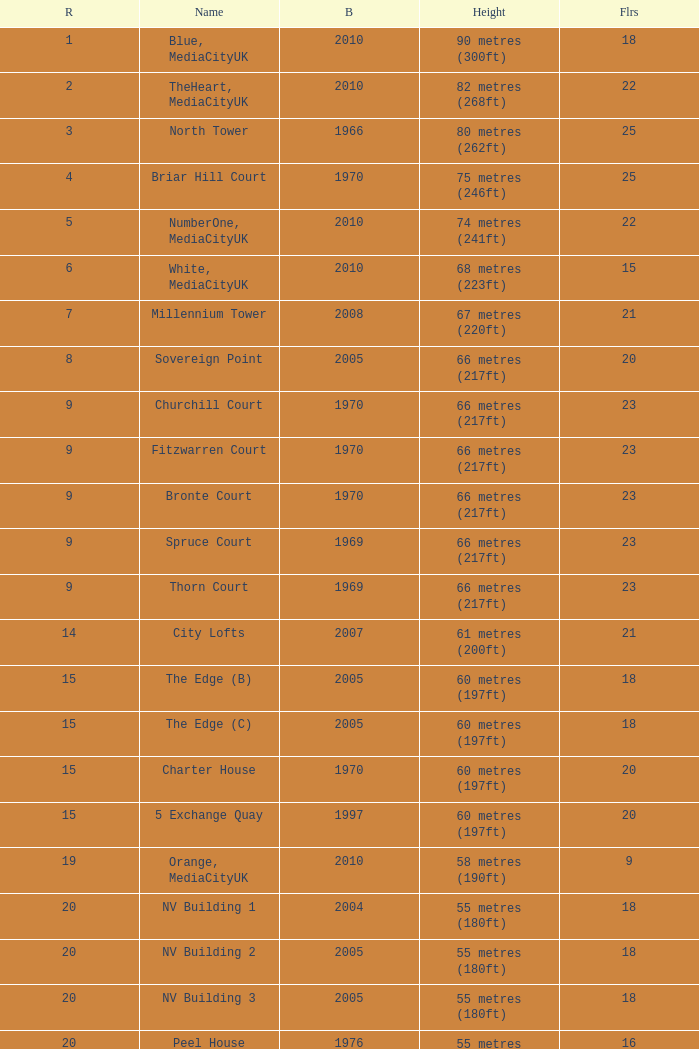What is the lowest Floors, when Built is greater than 1970, and when Name is NV Building 3? 18.0. 